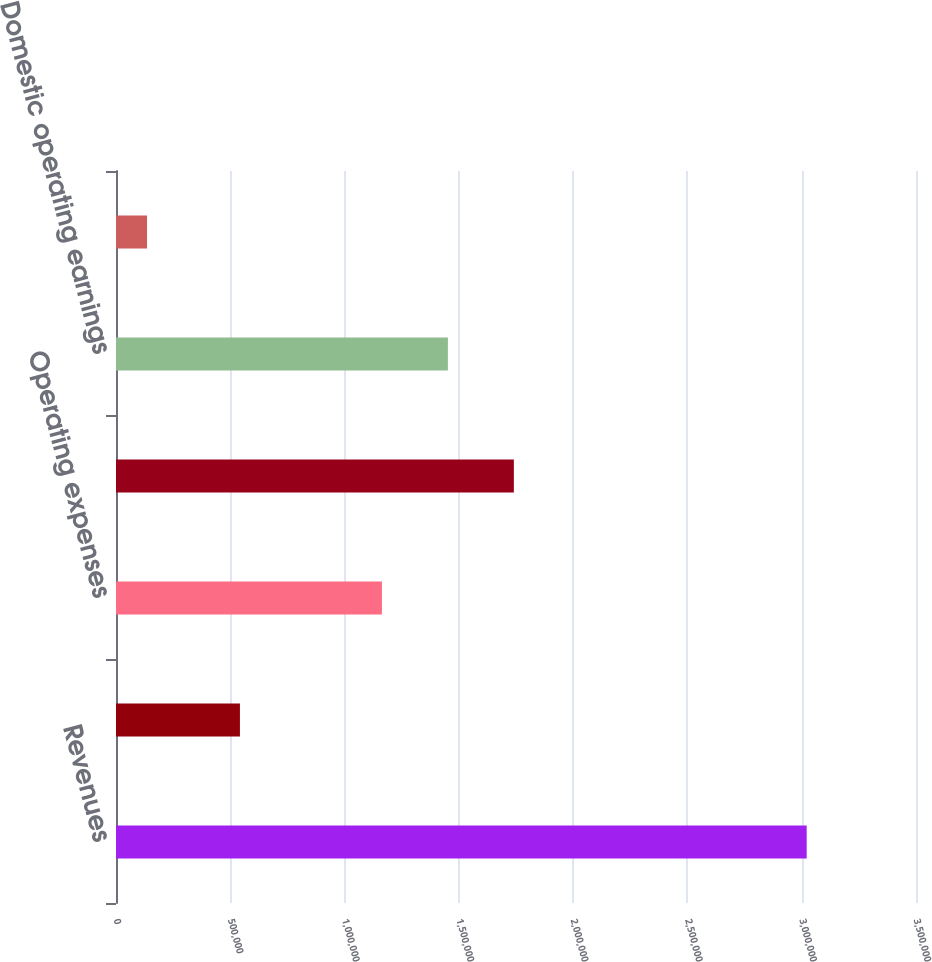<chart> <loc_0><loc_0><loc_500><loc_500><bar_chart><fcel>Revenues<fcel>Costs of revenue<fcel>Operating expenses<fcel>Total costs and expenses<fcel>Domestic operating earnings<fcel>Global operating earnings<nl><fcel>3.02179e+06<fcel>542210<fcel>1.16341e+06<fcel>1.74061e+06<fcel>1.45201e+06<fcel>135781<nl></chart> 